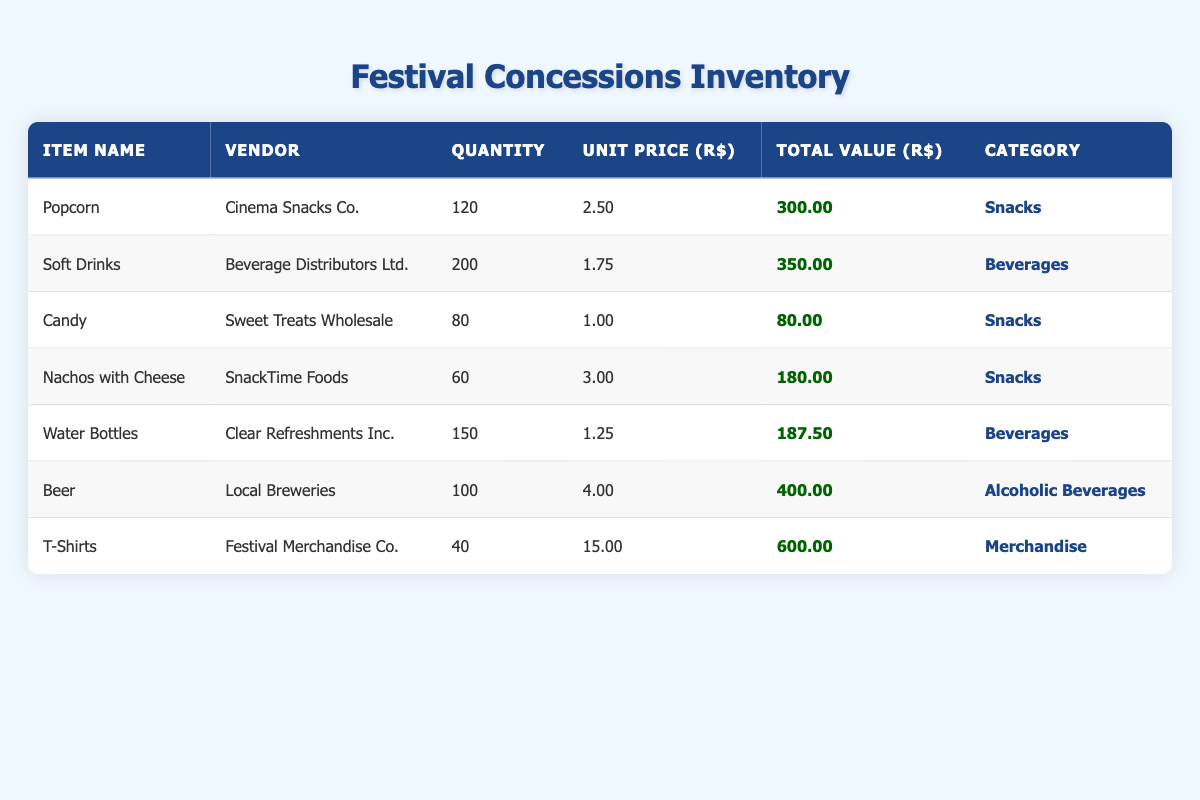What is the total quantity of snacks available? The snacks include Popcorn (120), Candy (80), and Nachos with Cheese (60). Adding these quantities gives us 120 + 80 + 60 = 260.
Answer: 260 How much is the total revenue expected from the soft drinks? The total value from soft drinks is given as 350.00.
Answer: 350.00 What item has the highest unit price? The items are Beer (4.00), T-Shirts (15.00), and others are lower. Comparing these values shows that T-Shirts have the highest unit price of 15.00.
Answer: T-Shirts Is the total value of nachos with cheese greater than that of candy? The total value for Nachos with Cheese is 180.00, whereas Candy's total value is 80.00. Since 180.00 > 80.00, the statement is true.
Answer: Yes What is the average unit price of beverages? The beverages are Soft Drinks (1.75) and Water Bottles (1.25). To find the average, sum the unit prices: 1.75 + 1.25 = 3.00 and divide by 2, so 3.00 / 2 = 1.50.
Answer: 1.50 Which vendor supplies the most quantity of a single item? Reviewing the quantities, Cinema Snacks Co. provides 120 (Popcorn), Beverage Distributors Ltd. provides 200 (Soft Drinks), Clear Refreshments Inc. provides 150 (Water Bottles). The largest quantity is from Beverage Distributors Ltd. at 200.
Answer: Beverage Distributors Ltd How much total value does the alcoholic beverages category have? The only item in the alcoholic beverages category is Beer, with a total value of 400.00.
Answer: 400.00 Is there any category with only one item? Reviewing the categories, Snacks contains three items, Beverages contains two items, Alcoholic Beverages has one item (Beer), and Merchandise has one item (T-Shirts). Thus, yes, both Alcoholic Beverages and Merchandise have only one item.
Answer: Yes What percentage of the total inventory value comes from T-Shirts? The total inventory value is calculated as 300 + 350 + 80 + 180 + 187.50 + 400 + 600 = 2097.50. The value for T-Shirts is 600. Therefore, (600 / 2097.50) * 100 gives approximately 28.64%.
Answer: 28.64% 